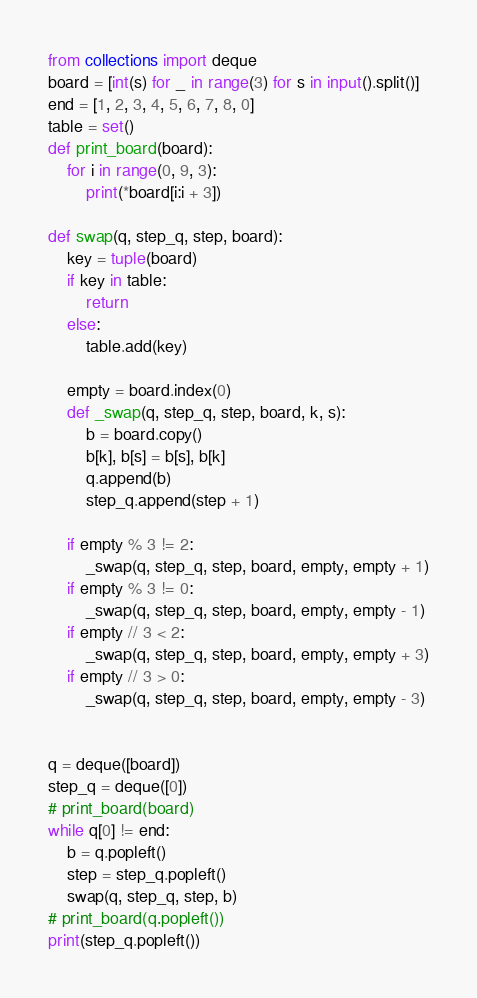Convert code to text. <code><loc_0><loc_0><loc_500><loc_500><_Python_>from collections import deque
board = [int(s) for _ in range(3) for s in input().split()]
end = [1, 2, 3, 4, 5, 6, 7, 8, 0]
table = set()
def print_board(board):
    for i in range(0, 9, 3):
        print(*board[i:i + 3])

def swap(q, step_q, step, board):
    key = tuple(board)
    if key in table:
        return
    else:
        table.add(key)

    empty = board.index(0)
    def _swap(q, step_q, step, board, k, s):
        b = board.copy()
        b[k], b[s] = b[s], b[k]
        q.append(b)
        step_q.append(step + 1)

    if empty % 3 != 2:
        _swap(q, step_q, step, board, empty, empty + 1)
    if empty % 3 != 0:
        _swap(q, step_q, step, board, empty, empty - 1)
    if empty // 3 < 2:
        _swap(q, step_q, step, board, empty, empty + 3)
    if empty // 3 > 0:
        _swap(q, step_q, step, board, empty, empty - 3)


q = deque([board])
step_q = deque([0])
# print_board(board)
while q[0] != end:
    b = q.popleft()
    step = step_q.popleft()
    swap(q, step_q, step, b)
# print_board(q.popleft())
print(step_q.popleft())
</code> 